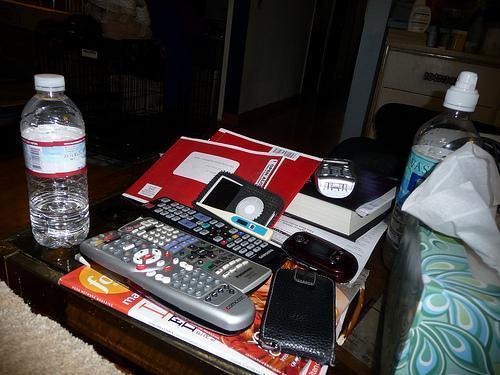How many iPods are there?
Give a very brief answer. 1. 